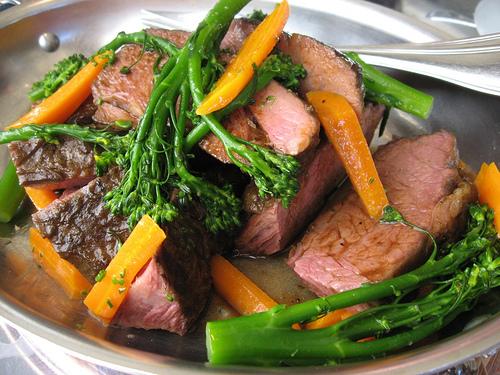Does this look like a healthy meal?
Answer briefly. Yes. What kind of meat is on the plate?
Be succinct. Beef. Is the meat burnt?
Write a very short answer. No. 